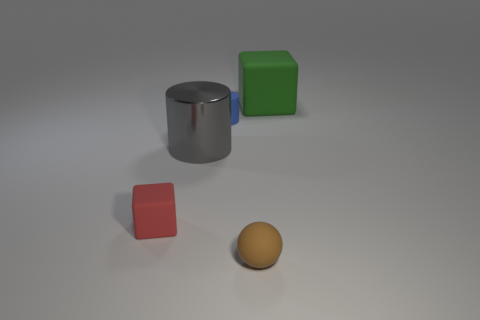What color is the large metal object that is the same shape as the small blue matte object?
Give a very brief answer. Gray. How many things are either red cubes or green blocks?
Provide a succinct answer. 2. There is a large thing that is made of the same material as the blue cylinder; what shape is it?
Give a very brief answer. Cube. What number of tiny objects are either spheres or yellow matte cylinders?
Offer a terse response. 1. How many other things are the same color as the ball?
Give a very brief answer. 0. There is a matte block to the left of the block that is on the right side of the small brown object; what number of gray cylinders are behind it?
Ensure brevity in your answer.  1. Does the matte block that is left of the gray object have the same size as the brown ball?
Provide a succinct answer. Yes. Is the number of large green matte objects that are on the left side of the big rubber block less than the number of cylinders in front of the small blue matte cylinder?
Your answer should be compact. Yes. Is the number of large cubes that are behind the green rubber cube less than the number of small matte blocks?
Ensure brevity in your answer.  Yes. Is the material of the gray cylinder the same as the tiny cube?
Keep it short and to the point. No. 